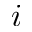Convert formula to latex. <formula><loc_0><loc_0><loc_500><loc_500>i</formula> 